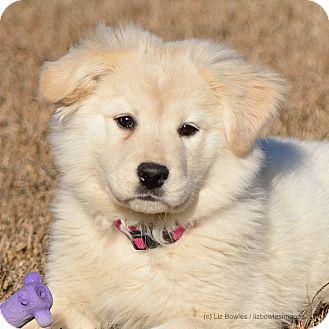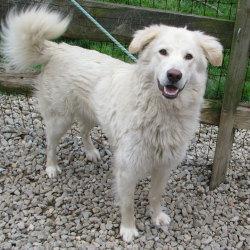The first image is the image on the left, the second image is the image on the right. Considering the images on both sides, is "At least one image has dogs sitting on grass." valid? Answer yes or no. No. 